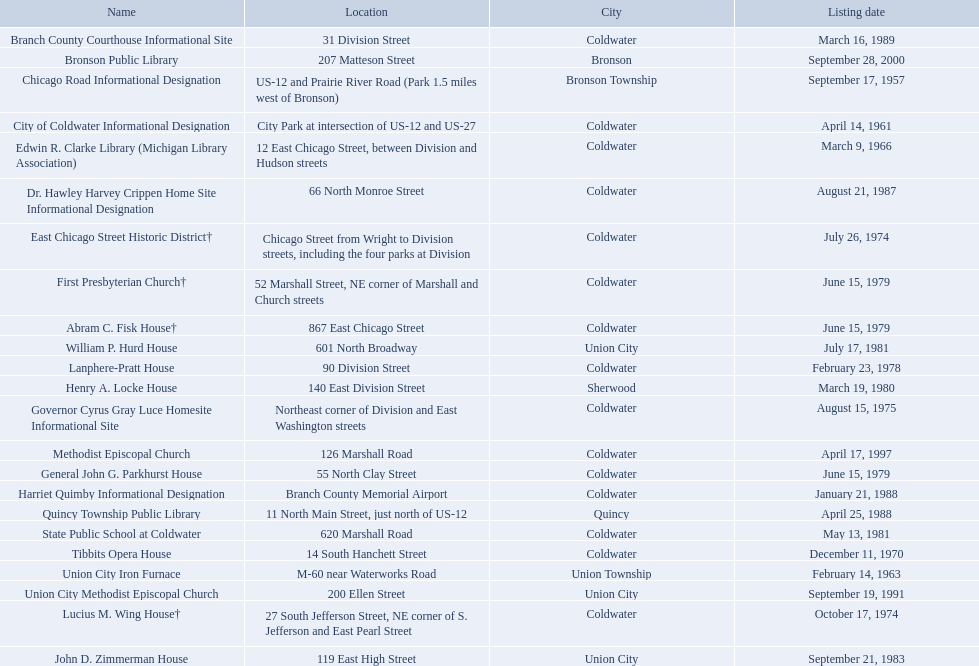What are all of the locations considered historical sites in branch county, michigan? Branch County Courthouse Informational Site, Bronson Public Library, Chicago Road Informational Designation, City of Coldwater Informational Designation, Edwin R. Clarke Library (Michigan Library Association), Dr. Hawley Harvey Crippen Home Site Informational Designation, East Chicago Street Historic District†, First Presbyterian Church†, Abram C. Fisk House†, William P. Hurd House, Lanphere-Pratt House, Henry A. Locke House, Governor Cyrus Gray Luce Homesite Informational Site, Methodist Episcopal Church, General John G. Parkhurst House, Harriet Quimby Informational Designation, Quincy Township Public Library, State Public School at Coldwater, Tibbits Opera House, Union City Iron Furnace, Union City Methodist Episcopal Church, Lucius M. Wing House†, John D. Zimmerman House. Of those sites, which one was the first to be listed as historical? Chicago Road Informational Designation. In branch co. mi what historic sites are located on a near a highway? Chicago Road Informational Designation, City of Coldwater Informational Designation, Quincy Township Public Library, Union City Iron Furnace. Of the historic sites ins branch co. near highways, which ones are near only us highways? Chicago Road Informational Designation, City of Coldwater Informational Designation, Quincy Township Public Library. Which historical sites in branch co. are near only us highways and are not a building? Chicago Road Informational Designation, City of Coldwater Informational Designation. Which non-building historical sites in branch county near a us highways is closest to bronson? Chicago Road Informational Designation. What are all the areas recognized as historical sites in branch county, michigan? Branch County Courthouse Informational Site, Bronson Public Library, Chicago Road Informational Designation, City of Coldwater Informational Designation, Edwin R. Clarke Library (Michigan Library Association), Dr. Hawley Harvey Crippen Home Site Informational Designation, East Chicago Street Historic District†, First Presbyterian Church†, Abram C. Fisk House†, William P. Hurd House, Lanphere-Pratt House, Henry A. Locke House, Governor Cyrus Gray Luce Homesite Informational Site, Methodist Episcopal Church, General John G. Parkhurst House, Harriet Quimby Informational Designation, Quincy Township Public Library, State Public School at Coldwater, Tibbits Opera House, Union City Iron Furnace, Union City Methodist Episcopal Church, Lucius M. Wing House†, John D. Zimmerman House. From those sites, which one was the initial one to be categorized as historical? Chicago Road Informational Designation. What are all the places regarded as historical sites in branch county, michigan? Branch County Courthouse Informational Site, Bronson Public Library, Chicago Road Informational Designation, City of Coldwater Informational Designation, Edwin R. Clarke Library (Michigan Library Association), Dr. Hawley Harvey Crippen Home Site Informational Designation, East Chicago Street Historic District†, First Presbyterian Church†, Abram C. Fisk House†, William P. Hurd House, Lanphere-Pratt House, Henry A. Locke House, Governor Cyrus Gray Luce Homesite Informational Site, Methodist Episcopal Church, General John G. Parkhurst House, Harriet Quimby Informational Designation, Quincy Township Public Library, State Public School at Coldwater, Tibbits Opera House, Union City Iron Furnace, Union City Methodist Episcopal Church, Lucius M. Wing House†, John D. Zimmerman House. Parse the full table in json format. {'header': ['Name', 'Location', 'City', 'Listing date'], 'rows': [['Branch County Courthouse Informational Site', '31 Division Street', 'Coldwater', 'March 16, 1989'], ['Bronson Public Library', '207 Matteson Street', 'Bronson', 'September 28, 2000'], ['Chicago Road Informational Designation', 'US-12 and Prairie River Road (Park 1.5 miles west of Bronson)', 'Bronson Township', 'September 17, 1957'], ['City of Coldwater Informational Designation', 'City Park at intersection of US-12 and US-27', 'Coldwater', 'April 14, 1961'], ['Edwin R. Clarke Library (Michigan Library Association)', '12 East Chicago Street, between Division and Hudson streets', 'Coldwater', 'March 9, 1966'], ['Dr. Hawley Harvey Crippen Home Site Informational Designation', '66 North Monroe Street', 'Coldwater', 'August 21, 1987'], ['East Chicago Street Historic District†', 'Chicago Street from Wright to Division streets, including the four parks at Division', 'Coldwater', 'July 26, 1974'], ['First Presbyterian Church†', '52 Marshall Street, NE corner of Marshall and Church streets', 'Coldwater', 'June 15, 1979'], ['Abram C. Fisk House†', '867 East Chicago Street', 'Coldwater', 'June 15, 1979'], ['William P. Hurd House', '601 North Broadway', 'Union City', 'July 17, 1981'], ['Lanphere-Pratt House', '90 Division Street', 'Coldwater', 'February 23, 1978'], ['Henry A. Locke House', '140 East Division Street', 'Sherwood', 'March 19, 1980'], ['Governor Cyrus Gray Luce Homesite Informational Site', 'Northeast corner of Division and East Washington streets', 'Coldwater', 'August 15, 1975'], ['Methodist Episcopal Church', '126 Marshall Road', 'Coldwater', 'April 17, 1997'], ['General John G. Parkhurst House', '55 North Clay Street', 'Coldwater', 'June 15, 1979'], ['Harriet Quimby Informational Designation', 'Branch County Memorial Airport', 'Coldwater', 'January 21, 1988'], ['Quincy Township Public Library', '11 North Main Street, just north of US-12', 'Quincy', 'April 25, 1988'], ['State Public School at Coldwater', '620 Marshall Road', 'Coldwater', 'May 13, 1981'], ['Tibbits Opera House', '14 South Hanchett Street', 'Coldwater', 'December 11, 1970'], ['Union City Iron Furnace', 'M-60 near Waterworks Road', 'Union Township', 'February 14, 1963'], ['Union City Methodist Episcopal Church', '200 Ellen Street', 'Union City', 'September 19, 1991'], ['Lucius M. Wing House†', '27 South Jefferson Street, NE corner of S. Jefferson and East Pearl Street', 'Coldwater', 'October 17, 1974'], ['John D. Zimmerman House', '119 East High Street', 'Union City', 'September 21, 1983']]} Among those sites, which one was the earliest to be designated as historical? Chicago Road Informational Designation. What historic locations can be found close to a highway in branch county, michigan? Chicago Road Informational Designation, City of Coldwater Informational Designation, Quincy Township Public Library, Union City Iron Furnace. Among these historic sites, which ones are situated near only us highways? Chicago Road Informational Designation, City of Coldwater Informational Designation, Quincy Township Public Library. Which historical landmarks in branch county are near solely us highways and are not buildings? Chicago Road Informational Designation, City of Coldwater Informational Designation. Which non-building historical landmarks in branch county, near a us highway, are closest to bronson? Chicago Road Informational Designation. Which historic places in branch county, michigan, are positioned near a highway? Chicago Road Informational Designation, City of Coldwater Informational Designation, Quincy Township Public Library, Union City Iron Furnace. Of these sites, which are adjacent to only us highways? Chicago Road Informational Designation, City of Coldwater Informational Designation, Quincy Township Public Library. Which historical locations in branch county are not buildings and are close to solely us highways? Chicago Road Informational Designation, City of Coldwater Informational Designation. Which non-building historical locations in branch county, close to a us highway, have the shortest distance to? Chicago Road Informational Designation. Were there any sites listed before the year 1960? September 17, 1957. What is the name of such a site that was listed earlier than 1960? Chicago Road Informational Designation. 